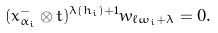Convert formula to latex. <formula><loc_0><loc_0><loc_500><loc_500>( x _ { \alpha _ { i } } ^ { - } \otimes t ) ^ { \lambda { ( h _ { i } ) } + 1 } w _ { \ell \omega _ { i } + \lambda } = 0 .</formula> 